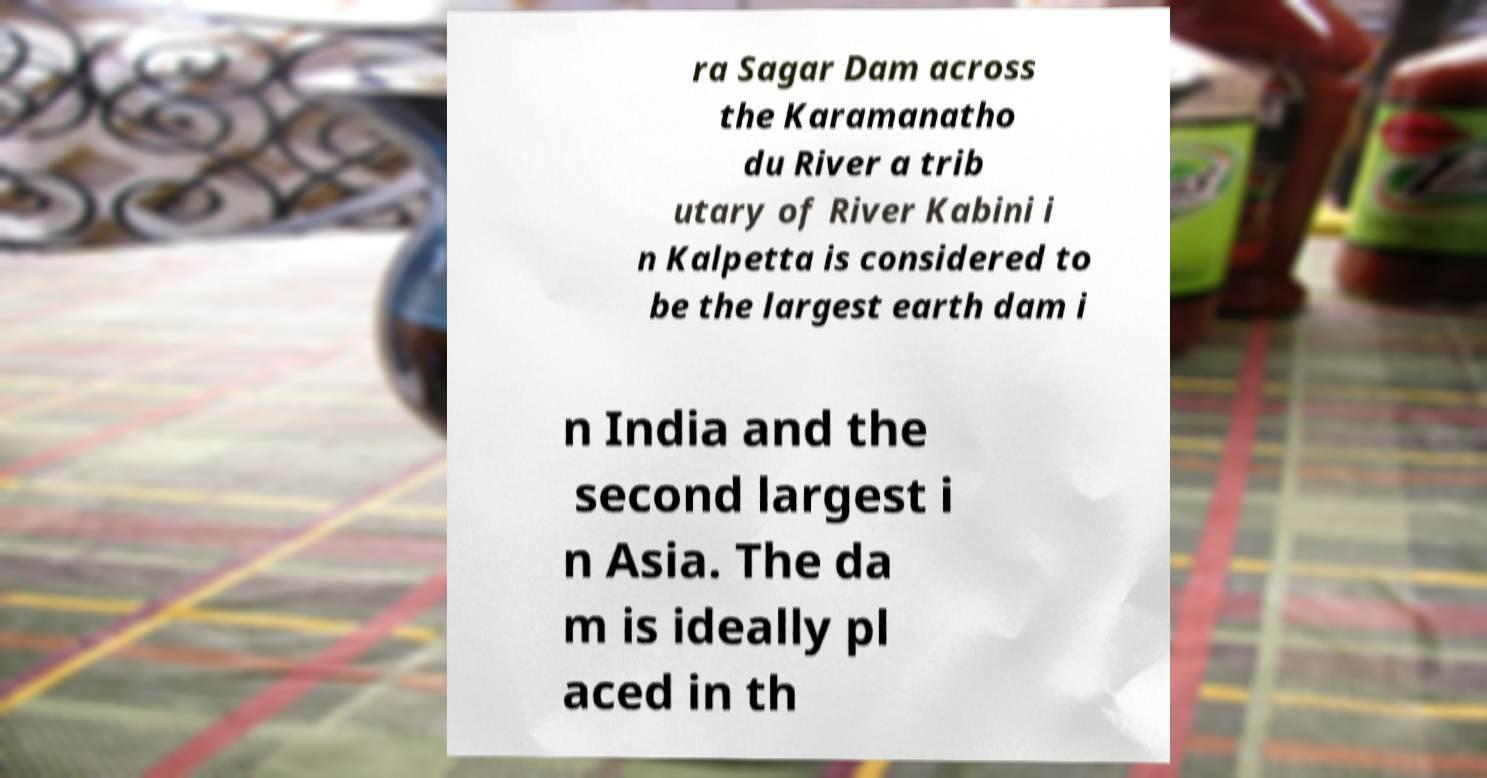Please identify and transcribe the text found in this image. ra Sagar Dam across the Karamanatho du River a trib utary of River Kabini i n Kalpetta is considered to be the largest earth dam i n India and the second largest i n Asia. The da m is ideally pl aced in th 